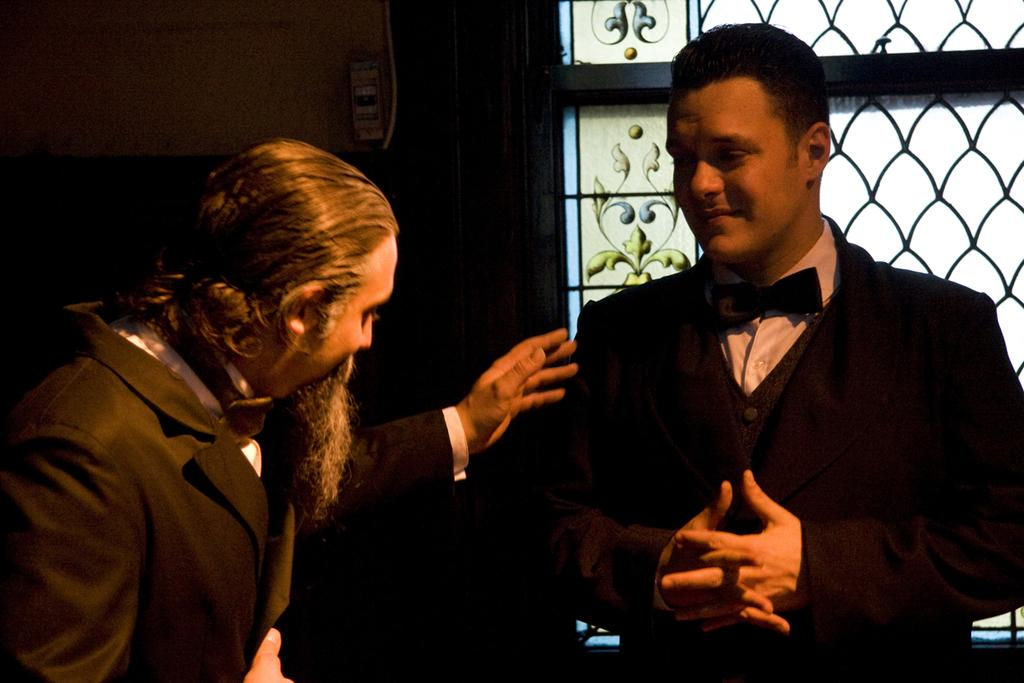How many people are in the image? There are two persons in the image. What can be seen in the background of the image? There is a metal fence in the image. Can you describe any design elements in the image? Yes, there is a design on a glass window in the image. What is the tax rate for the sugar industry in the image? There is no information about tax rates or the sugar industry in the image. 